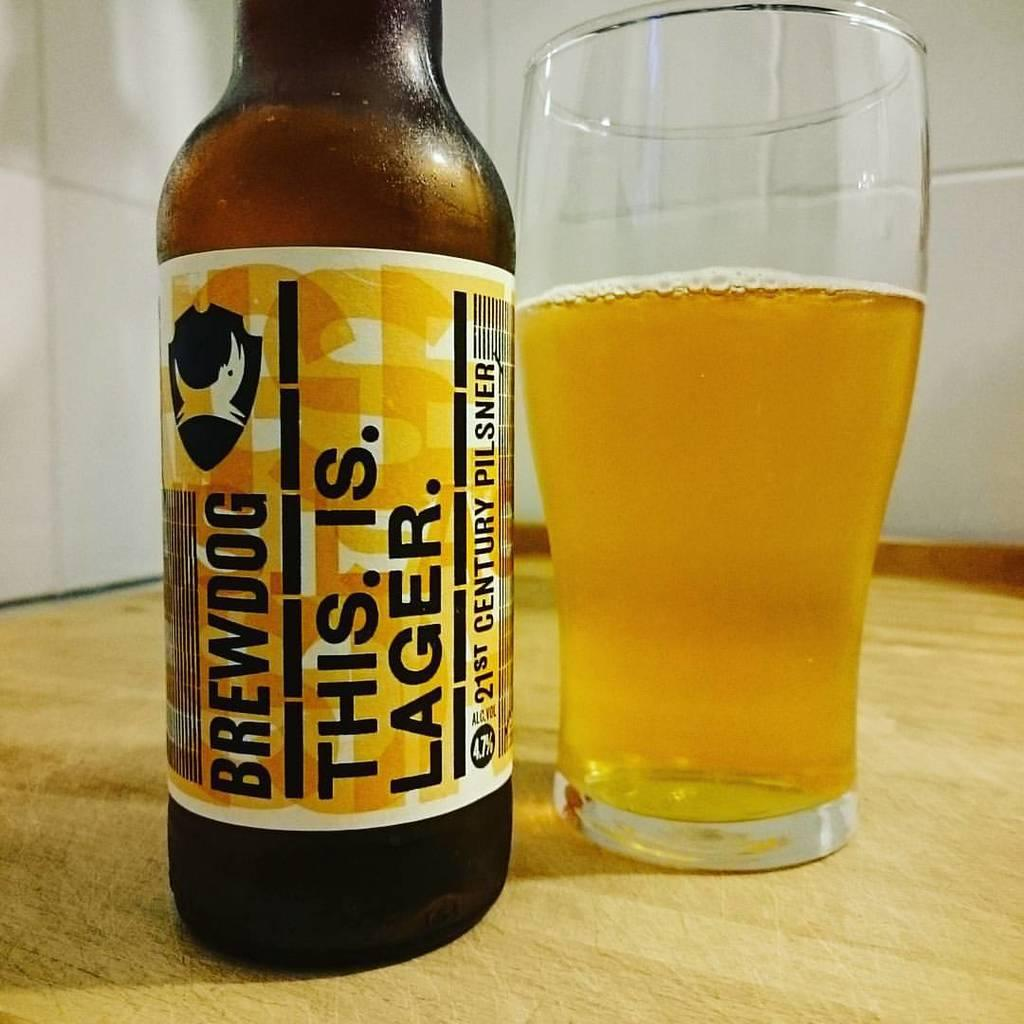Provide a one-sentence caption for the provided image. A This. Is. Lager. Brewdog beer next to a glass with some beer in it. 